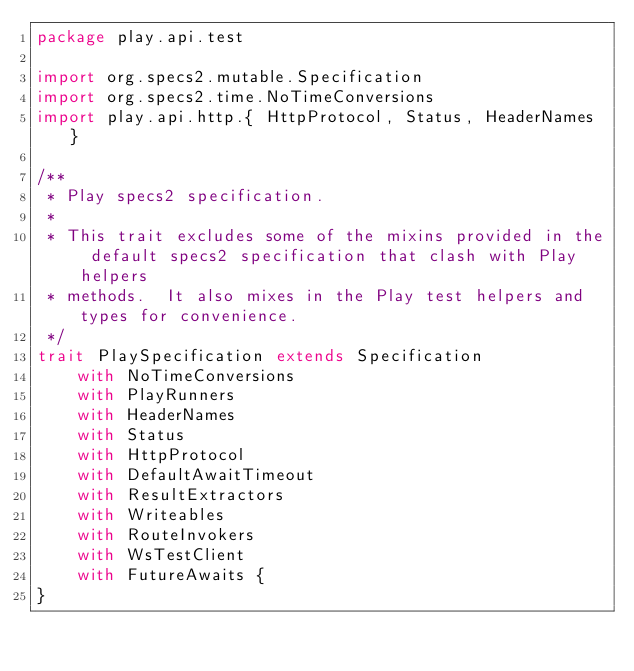<code> <loc_0><loc_0><loc_500><loc_500><_Scala_>package play.api.test

import org.specs2.mutable.Specification
import org.specs2.time.NoTimeConversions
import play.api.http.{ HttpProtocol, Status, HeaderNames }

/**
 * Play specs2 specification.
 *
 * This trait excludes some of the mixins provided in the default specs2 specification that clash with Play helpers
 * methods.  It also mixes in the Play test helpers and types for convenience.
 */
trait PlaySpecification extends Specification
    with NoTimeConversions
    with PlayRunners
    with HeaderNames
    with Status
    with HttpProtocol
    with DefaultAwaitTimeout
    with ResultExtractors
    with Writeables
    with RouteInvokers
    with WsTestClient
    with FutureAwaits {
}</code> 